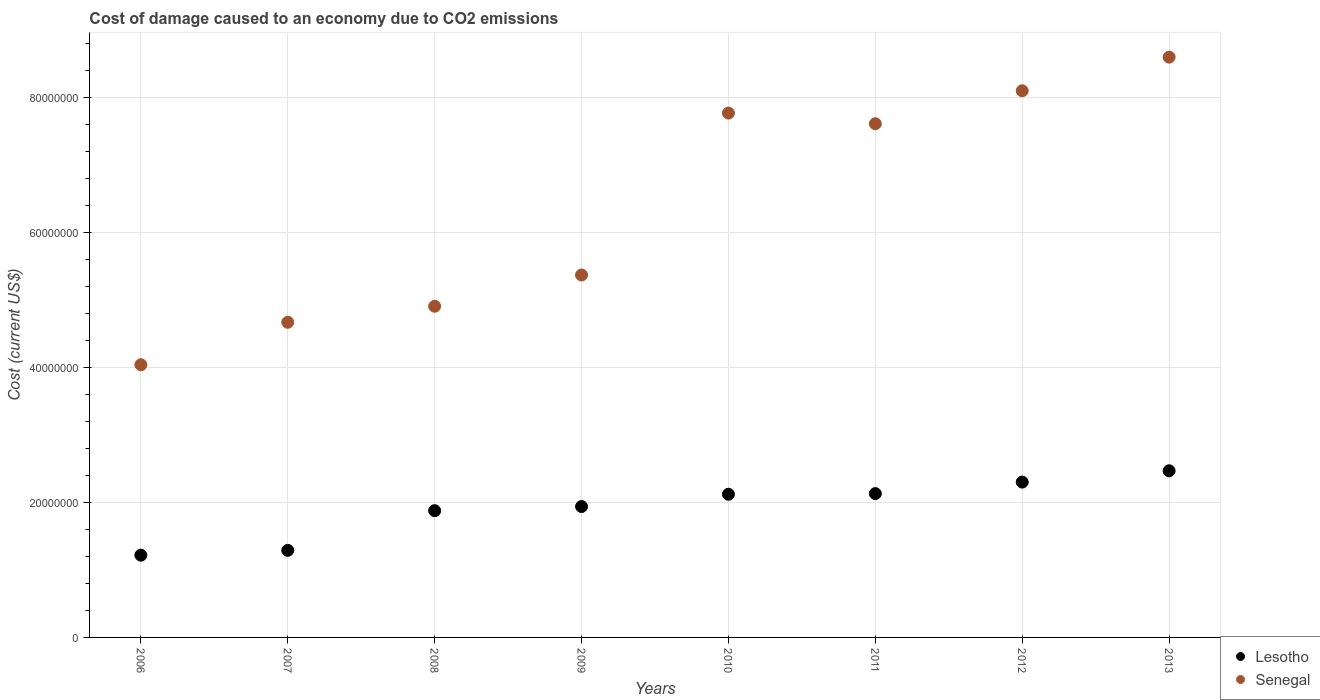How many different coloured dotlines are there?
Ensure brevity in your answer.  2. Is the number of dotlines equal to the number of legend labels?
Provide a succinct answer. Yes. What is the cost of damage caused due to CO2 emissisons in Lesotho in 2008?
Offer a very short reply. 1.88e+07. Across all years, what is the maximum cost of damage caused due to CO2 emissisons in Lesotho?
Your answer should be very brief. 2.47e+07. Across all years, what is the minimum cost of damage caused due to CO2 emissisons in Lesotho?
Make the answer very short. 1.22e+07. In which year was the cost of damage caused due to CO2 emissisons in Lesotho maximum?
Keep it short and to the point. 2013. In which year was the cost of damage caused due to CO2 emissisons in Lesotho minimum?
Your answer should be compact. 2006. What is the total cost of damage caused due to CO2 emissisons in Senegal in the graph?
Your response must be concise. 5.11e+08. What is the difference between the cost of damage caused due to CO2 emissisons in Lesotho in 2010 and that in 2012?
Ensure brevity in your answer.  -1.80e+06. What is the difference between the cost of damage caused due to CO2 emissisons in Senegal in 2011 and the cost of damage caused due to CO2 emissisons in Lesotho in 2012?
Your answer should be compact. 5.31e+07. What is the average cost of damage caused due to CO2 emissisons in Senegal per year?
Offer a very short reply. 6.39e+07. In the year 2010, what is the difference between the cost of damage caused due to CO2 emissisons in Lesotho and cost of damage caused due to CO2 emissisons in Senegal?
Your answer should be compact. -5.65e+07. In how many years, is the cost of damage caused due to CO2 emissisons in Senegal greater than 84000000 US$?
Keep it short and to the point. 1. What is the ratio of the cost of damage caused due to CO2 emissisons in Senegal in 2006 to that in 2007?
Provide a succinct answer. 0.87. Is the difference between the cost of damage caused due to CO2 emissisons in Lesotho in 2007 and 2010 greater than the difference between the cost of damage caused due to CO2 emissisons in Senegal in 2007 and 2010?
Ensure brevity in your answer.  Yes. What is the difference between the highest and the second highest cost of damage caused due to CO2 emissisons in Lesotho?
Make the answer very short. 1.68e+06. What is the difference between the highest and the lowest cost of damage caused due to CO2 emissisons in Lesotho?
Give a very brief answer. 1.25e+07. In how many years, is the cost of damage caused due to CO2 emissisons in Lesotho greater than the average cost of damage caused due to CO2 emissisons in Lesotho taken over all years?
Provide a succinct answer. 5. Is the sum of the cost of damage caused due to CO2 emissisons in Lesotho in 2009 and 2011 greater than the maximum cost of damage caused due to CO2 emissisons in Senegal across all years?
Your response must be concise. No. Is the cost of damage caused due to CO2 emissisons in Senegal strictly greater than the cost of damage caused due to CO2 emissisons in Lesotho over the years?
Your answer should be very brief. Yes. Is the cost of damage caused due to CO2 emissisons in Senegal strictly less than the cost of damage caused due to CO2 emissisons in Lesotho over the years?
Offer a terse response. No. How many dotlines are there?
Offer a terse response. 2. What is the difference between two consecutive major ticks on the Y-axis?
Offer a terse response. 2.00e+07. Are the values on the major ticks of Y-axis written in scientific E-notation?
Your answer should be compact. No. Does the graph contain any zero values?
Provide a succinct answer. No. Where does the legend appear in the graph?
Provide a short and direct response. Bottom right. How are the legend labels stacked?
Offer a terse response. Vertical. What is the title of the graph?
Your answer should be compact. Cost of damage caused to an economy due to CO2 emissions. Does "Rwanda" appear as one of the legend labels in the graph?
Offer a very short reply. No. What is the label or title of the X-axis?
Make the answer very short. Years. What is the label or title of the Y-axis?
Ensure brevity in your answer.  Cost (current US$). What is the Cost (current US$) of Lesotho in 2006?
Ensure brevity in your answer.  1.22e+07. What is the Cost (current US$) in Senegal in 2006?
Offer a terse response. 4.04e+07. What is the Cost (current US$) in Lesotho in 2007?
Offer a terse response. 1.29e+07. What is the Cost (current US$) in Senegal in 2007?
Your answer should be compact. 4.67e+07. What is the Cost (current US$) of Lesotho in 2008?
Your answer should be very brief. 1.88e+07. What is the Cost (current US$) of Senegal in 2008?
Provide a short and direct response. 4.91e+07. What is the Cost (current US$) in Lesotho in 2009?
Make the answer very short. 1.94e+07. What is the Cost (current US$) in Senegal in 2009?
Offer a terse response. 5.37e+07. What is the Cost (current US$) of Lesotho in 2010?
Keep it short and to the point. 2.12e+07. What is the Cost (current US$) in Senegal in 2010?
Your answer should be compact. 7.77e+07. What is the Cost (current US$) of Lesotho in 2011?
Offer a very short reply. 2.13e+07. What is the Cost (current US$) in Senegal in 2011?
Make the answer very short. 7.62e+07. What is the Cost (current US$) in Lesotho in 2012?
Provide a succinct answer. 2.30e+07. What is the Cost (current US$) of Senegal in 2012?
Make the answer very short. 8.11e+07. What is the Cost (current US$) of Lesotho in 2013?
Your answer should be compact. 2.47e+07. What is the Cost (current US$) in Senegal in 2013?
Make the answer very short. 8.60e+07. Across all years, what is the maximum Cost (current US$) in Lesotho?
Keep it short and to the point. 2.47e+07. Across all years, what is the maximum Cost (current US$) of Senegal?
Keep it short and to the point. 8.60e+07. Across all years, what is the minimum Cost (current US$) of Lesotho?
Offer a terse response. 1.22e+07. Across all years, what is the minimum Cost (current US$) of Senegal?
Keep it short and to the point. 4.04e+07. What is the total Cost (current US$) of Lesotho in the graph?
Ensure brevity in your answer.  1.54e+08. What is the total Cost (current US$) of Senegal in the graph?
Offer a terse response. 5.11e+08. What is the difference between the Cost (current US$) in Lesotho in 2006 and that in 2007?
Your answer should be compact. -7.13e+05. What is the difference between the Cost (current US$) of Senegal in 2006 and that in 2007?
Provide a succinct answer. -6.30e+06. What is the difference between the Cost (current US$) in Lesotho in 2006 and that in 2008?
Provide a short and direct response. -6.60e+06. What is the difference between the Cost (current US$) in Senegal in 2006 and that in 2008?
Make the answer very short. -8.67e+06. What is the difference between the Cost (current US$) in Lesotho in 2006 and that in 2009?
Ensure brevity in your answer.  -7.21e+06. What is the difference between the Cost (current US$) in Senegal in 2006 and that in 2009?
Provide a succinct answer. -1.33e+07. What is the difference between the Cost (current US$) of Lesotho in 2006 and that in 2010?
Offer a very short reply. -9.03e+06. What is the difference between the Cost (current US$) of Senegal in 2006 and that in 2010?
Make the answer very short. -3.73e+07. What is the difference between the Cost (current US$) in Lesotho in 2006 and that in 2011?
Give a very brief answer. -9.13e+06. What is the difference between the Cost (current US$) in Senegal in 2006 and that in 2011?
Make the answer very short. -3.57e+07. What is the difference between the Cost (current US$) of Lesotho in 2006 and that in 2012?
Provide a succinct answer. -1.08e+07. What is the difference between the Cost (current US$) in Senegal in 2006 and that in 2012?
Ensure brevity in your answer.  -4.06e+07. What is the difference between the Cost (current US$) of Lesotho in 2006 and that in 2013?
Give a very brief answer. -1.25e+07. What is the difference between the Cost (current US$) in Senegal in 2006 and that in 2013?
Offer a terse response. -4.56e+07. What is the difference between the Cost (current US$) in Lesotho in 2007 and that in 2008?
Make the answer very short. -5.88e+06. What is the difference between the Cost (current US$) in Senegal in 2007 and that in 2008?
Make the answer very short. -2.38e+06. What is the difference between the Cost (current US$) in Lesotho in 2007 and that in 2009?
Offer a terse response. -6.50e+06. What is the difference between the Cost (current US$) of Senegal in 2007 and that in 2009?
Give a very brief answer. -7.01e+06. What is the difference between the Cost (current US$) of Lesotho in 2007 and that in 2010?
Provide a succinct answer. -8.32e+06. What is the difference between the Cost (current US$) in Senegal in 2007 and that in 2010?
Keep it short and to the point. -3.10e+07. What is the difference between the Cost (current US$) of Lesotho in 2007 and that in 2011?
Your response must be concise. -8.42e+06. What is the difference between the Cost (current US$) in Senegal in 2007 and that in 2011?
Offer a very short reply. -2.94e+07. What is the difference between the Cost (current US$) of Lesotho in 2007 and that in 2012?
Offer a very short reply. -1.01e+07. What is the difference between the Cost (current US$) in Senegal in 2007 and that in 2012?
Offer a very short reply. -3.43e+07. What is the difference between the Cost (current US$) in Lesotho in 2007 and that in 2013?
Offer a terse response. -1.18e+07. What is the difference between the Cost (current US$) of Senegal in 2007 and that in 2013?
Keep it short and to the point. -3.93e+07. What is the difference between the Cost (current US$) of Lesotho in 2008 and that in 2009?
Make the answer very short. -6.11e+05. What is the difference between the Cost (current US$) of Senegal in 2008 and that in 2009?
Provide a succinct answer. -4.63e+06. What is the difference between the Cost (current US$) in Lesotho in 2008 and that in 2010?
Provide a short and direct response. -2.43e+06. What is the difference between the Cost (current US$) of Senegal in 2008 and that in 2010?
Offer a very short reply. -2.86e+07. What is the difference between the Cost (current US$) in Lesotho in 2008 and that in 2011?
Keep it short and to the point. -2.53e+06. What is the difference between the Cost (current US$) in Senegal in 2008 and that in 2011?
Offer a very short reply. -2.71e+07. What is the difference between the Cost (current US$) in Lesotho in 2008 and that in 2012?
Keep it short and to the point. -4.24e+06. What is the difference between the Cost (current US$) of Senegal in 2008 and that in 2012?
Provide a succinct answer. -3.20e+07. What is the difference between the Cost (current US$) of Lesotho in 2008 and that in 2013?
Your response must be concise. -5.91e+06. What is the difference between the Cost (current US$) in Senegal in 2008 and that in 2013?
Provide a short and direct response. -3.69e+07. What is the difference between the Cost (current US$) in Lesotho in 2009 and that in 2010?
Your response must be concise. -1.82e+06. What is the difference between the Cost (current US$) in Senegal in 2009 and that in 2010?
Your answer should be compact. -2.40e+07. What is the difference between the Cost (current US$) of Lesotho in 2009 and that in 2011?
Offer a terse response. -1.92e+06. What is the difference between the Cost (current US$) in Senegal in 2009 and that in 2011?
Ensure brevity in your answer.  -2.24e+07. What is the difference between the Cost (current US$) in Lesotho in 2009 and that in 2012?
Ensure brevity in your answer.  -3.63e+06. What is the difference between the Cost (current US$) in Senegal in 2009 and that in 2012?
Give a very brief answer. -2.73e+07. What is the difference between the Cost (current US$) of Lesotho in 2009 and that in 2013?
Your answer should be compact. -5.30e+06. What is the difference between the Cost (current US$) of Senegal in 2009 and that in 2013?
Your response must be concise. -3.23e+07. What is the difference between the Cost (current US$) in Lesotho in 2010 and that in 2011?
Provide a succinct answer. -9.74e+04. What is the difference between the Cost (current US$) in Senegal in 2010 and that in 2011?
Offer a very short reply. 1.58e+06. What is the difference between the Cost (current US$) in Lesotho in 2010 and that in 2012?
Your response must be concise. -1.80e+06. What is the difference between the Cost (current US$) of Senegal in 2010 and that in 2012?
Provide a succinct answer. -3.31e+06. What is the difference between the Cost (current US$) of Lesotho in 2010 and that in 2013?
Your response must be concise. -3.48e+06. What is the difference between the Cost (current US$) in Senegal in 2010 and that in 2013?
Provide a short and direct response. -8.29e+06. What is the difference between the Cost (current US$) of Lesotho in 2011 and that in 2012?
Your answer should be compact. -1.71e+06. What is the difference between the Cost (current US$) in Senegal in 2011 and that in 2012?
Provide a short and direct response. -4.89e+06. What is the difference between the Cost (current US$) in Lesotho in 2011 and that in 2013?
Offer a terse response. -3.38e+06. What is the difference between the Cost (current US$) of Senegal in 2011 and that in 2013?
Make the answer very short. -9.87e+06. What is the difference between the Cost (current US$) of Lesotho in 2012 and that in 2013?
Ensure brevity in your answer.  -1.68e+06. What is the difference between the Cost (current US$) in Senegal in 2012 and that in 2013?
Ensure brevity in your answer.  -4.98e+06. What is the difference between the Cost (current US$) of Lesotho in 2006 and the Cost (current US$) of Senegal in 2007?
Offer a very short reply. -3.45e+07. What is the difference between the Cost (current US$) in Lesotho in 2006 and the Cost (current US$) in Senegal in 2008?
Provide a succinct answer. -3.69e+07. What is the difference between the Cost (current US$) of Lesotho in 2006 and the Cost (current US$) of Senegal in 2009?
Ensure brevity in your answer.  -4.15e+07. What is the difference between the Cost (current US$) of Lesotho in 2006 and the Cost (current US$) of Senegal in 2010?
Give a very brief answer. -6.55e+07. What is the difference between the Cost (current US$) in Lesotho in 2006 and the Cost (current US$) in Senegal in 2011?
Provide a succinct answer. -6.40e+07. What is the difference between the Cost (current US$) in Lesotho in 2006 and the Cost (current US$) in Senegal in 2012?
Your answer should be compact. -6.89e+07. What is the difference between the Cost (current US$) of Lesotho in 2006 and the Cost (current US$) of Senegal in 2013?
Make the answer very short. -7.38e+07. What is the difference between the Cost (current US$) in Lesotho in 2007 and the Cost (current US$) in Senegal in 2008?
Keep it short and to the point. -3.62e+07. What is the difference between the Cost (current US$) of Lesotho in 2007 and the Cost (current US$) of Senegal in 2009?
Your answer should be compact. -4.08e+07. What is the difference between the Cost (current US$) of Lesotho in 2007 and the Cost (current US$) of Senegal in 2010?
Keep it short and to the point. -6.48e+07. What is the difference between the Cost (current US$) of Lesotho in 2007 and the Cost (current US$) of Senegal in 2011?
Keep it short and to the point. -6.33e+07. What is the difference between the Cost (current US$) in Lesotho in 2007 and the Cost (current US$) in Senegal in 2012?
Your answer should be very brief. -6.81e+07. What is the difference between the Cost (current US$) in Lesotho in 2007 and the Cost (current US$) in Senegal in 2013?
Your response must be concise. -7.31e+07. What is the difference between the Cost (current US$) of Lesotho in 2008 and the Cost (current US$) of Senegal in 2009?
Your answer should be very brief. -3.49e+07. What is the difference between the Cost (current US$) of Lesotho in 2008 and the Cost (current US$) of Senegal in 2010?
Make the answer very short. -5.90e+07. What is the difference between the Cost (current US$) of Lesotho in 2008 and the Cost (current US$) of Senegal in 2011?
Make the answer very short. -5.74e+07. What is the difference between the Cost (current US$) of Lesotho in 2008 and the Cost (current US$) of Senegal in 2012?
Provide a succinct answer. -6.23e+07. What is the difference between the Cost (current US$) in Lesotho in 2008 and the Cost (current US$) in Senegal in 2013?
Keep it short and to the point. -6.72e+07. What is the difference between the Cost (current US$) of Lesotho in 2009 and the Cost (current US$) of Senegal in 2010?
Your response must be concise. -5.83e+07. What is the difference between the Cost (current US$) in Lesotho in 2009 and the Cost (current US$) in Senegal in 2011?
Offer a terse response. -5.68e+07. What is the difference between the Cost (current US$) of Lesotho in 2009 and the Cost (current US$) of Senegal in 2012?
Provide a succinct answer. -6.17e+07. What is the difference between the Cost (current US$) in Lesotho in 2009 and the Cost (current US$) in Senegal in 2013?
Your response must be concise. -6.66e+07. What is the difference between the Cost (current US$) of Lesotho in 2010 and the Cost (current US$) of Senegal in 2011?
Provide a succinct answer. -5.49e+07. What is the difference between the Cost (current US$) of Lesotho in 2010 and the Cost (current US$) of Senegal in 2012?
Provide a succinct answer. -5.98e+07. What is the difference between the Cost (current US$) in Lesotho in 2010 and the Cost (current US$) in Senegal in 2013?
Your response must be concise. -6.48e+07. What is the difference between the Cost (current US$) in Lesotho in 2011 and the Cost (current US$) in Senegal in 2012?
Make the answer very short. -5.97e+07. What is the difference between the Cost (current US$) in Lesotho in 2011 and the Cost (current US$) in Senegal in 2013?
Provide a short and direct response. -6.47e+07. What is the difference between the Cost (current US$) of Lesotho in 2012 and the Cost (current US$) of Senegal in 2013?
Your answer should be compact. -6.30e+07. What is the average Cost (current US$) of Lesotho per year?
Ensure brevity in your answer.  1.92e+07. What is the average Cost (current US$) in Senegal per year?
Ensure brevity in your answer.  6.39e+07. In the year 2006, what is the difference between the Cost (current US$) of Lesotho and Cost (current US$) of Senegal?
Your answer should be compact. -2.82e+07. In the year 2007, what is the difference between the Cost (current US$) of Lesotho and Cost (current US$) of Senegal?
Your answer should be compact. -3.38e+07. In the year 2008, what is the difference between the Cost (current US$) in Lesotho and Cost (current US$) in Senegal?
Offer a terse response. -3.03e+07. In the year 2009, what is the difference between the Cost (current US$) in Lesotho and Cost (current US$) in Senegal?
Provide a succinct answer. -3.43e+07. In the year 2010, what is the difference between the Cost (current US$) in Lesotho and Cost (current US$) in Senegal?
Keep it short and to the point. -5.65e+07. In the year 2011, what is the difference between the Cost (current US$) of Lesotho and Cost (current US$) of Senegal?
Give a very brief answer. -5.48e+07. In the year 2012, what is the difference between the Cost (current US$) of Lesotho and Cost (current US$) of Senegal?
Offer a very short reply. -5.80e+07. In the year 2013, what is the difference between the Cost (current US$) of Lesotho and Cost (current US$) of Senegal?
Keep it short and to the point. -6.13e+07. What is the ratio of the Cost (current US$) of Lesotho in 2006 to that in 2007?
Your answer should be compact. 0.94. What is the ratio of the Cost (current US$) of Senegal in 2006 to that in 2007?
Your answer should be very brief. 0.87. What is the ratio of the Cost (current US$) of Lesotho in 2006 to that in 2008?
Make the answer very short. 0.65. What is the ratio of the Cost (current US$) in Senegal in 2006 to that in 2008?
Make the answer very short. 0.82. What is the ratio of the Cost (current US$) in Lesotho in 2006 to that in 2009?
Ensure brevity in your answer.  0.63. What is the ratio of the Cost (current US$) of Senegal in 2006 to that in 2009?
Provide a succinct answer. 0.75. What is the ratio of the Cost (current US$) of Lesotho in 2006 to that in 2010?
Your answer should be very brief. 0.57. What is the ratio of the Cost (current US$) in Senegal in 2006 to that in 2010?
Offer a terse response. 0.52. What is the ratio of the Cost (current US$) of Lesotho in 2006 to that in 2011?
Give a very brief answer. 0.57. What is the ratio of the Cost (current US$) in Senegal in 2006 to that in 2011?
Offer a terse response. 0.53. What is the ratio of the Cost (current US$) in Lesotho in 2006 to that in 2012?
Make the answer very short. 0.53. What is the ratio of the Cost (current US$) in Senegal in 2006 to that in 2012?
Provide a short and direct response. 0.5. What is the ratio of the Cost (current US$) in Lesotho in 2006 to that in 2013?
Provide a short and direct response. 0.49. What is the ratio of the Cost (current US$) of Senegal in 2006 to that in 2013?
Your response must be concise. 0.47. What is the ratio of the Cost (current US$) of Lesotho in 2007 to that in 2008?
Provide a succinct answer. 0.69. What is the ratio of the Cost (current US$) of Senegal in 2007 to that in 2008?
Keep it short and to the point. 0.95. What is the ratio of the Cost (current US$) of Lesotho in 2007 to that in 2009?
Your response must be concise. 0.67. What is the ratio of the Cost (current US$) in Senegal in 2007 to that in 2009?
Your response must be concise. 0.87. What is the ratio of the Cost (current US$) of Lesotho in 2007 to that in 2010?
Provide a succinct answer. 0.61. What is the ratio of the Cost (current US$) in Senegal in 2007 to that in 2010?
Your answer should be compact. 0.6. What is the ratio of the Cost (current US$) in Lesotho in 2007 to that in 2011?
Offer a terse response. 0.61. What is the ratio of the Cost (current US$) in Senegal in 2007 to that in 2011?
Your response must be concise. 0.61. What is the ratio of the Cost (current US$) in Lesotho in 2007 to that in 2012?
Ensure brevity in your answer.  0.56. What is the ratio of the Cost (current US$) in Senegal in 2007 to that in 2012?
Offer a very short reply. 0.58. What is the ratio of the Cost (current US$) of Lesotho in 2007 to that in 2013?
Your answer should be compact. 0.52. What is the ratio of the Cost (current US$) in Senegal in 2007 to that in 2013?
Keep it short and to the point. 0.54. What is the ratio of the Cost (current US$) in Lesotho in 2008 to that in 2009?
Provide a succinct answer. 0.97. What is the ratio of the Cost (current US$) in Senegal in 2008 to that in 2009?
Offer a terse response. 0.91. What is the ratio of the Cost (current US$) in Lesotho in 2008 to that in 2010?
Make the answer very short. 0.89. What is the ratio of the Cost (current US$) of Senegal in 2008 to that in 2010?
Keep it short and to the point. 0.63. What is the ratio of the Cost (current US$) in Lesotho in 2008 to that in 2011?
Provide a short and direct response. 0.88. What is the ratio of the Cost (current US$) of Senegal in 2008 to that in 2011?
Provide a short and direct response. 0.64. What is the ratio of the Cost (current US$) of Lesotho in 2008 to that in 2012?
Your answer should be very brief. 0.82. What is the ratio of the Cost (current US$) in Senegal in 2008 to that in 2012?
Your answer should be very brief. 0.61. What is the ratio of the Cost (current US$) of Lesotho in 2008 to that in 2013?
Make the answer very short. 0.76. What is the ratio of the Cost (current US$) in Senegal in 2008 to that in 2013?
Your response must be concise. 0.57. What is the ratio of the Cost (current US$) in Lesotho in 2009 to that in 2010?
Make the answer very short. 0.91. What is the ratio of the Cost (current US$) of Senegal in 2009 to that in 2010?
Ensure brevity in your answer.  0.69. What is the ratio of the Cost (current US$) in Lesotho in 2009 to that in 2011?
Your answer should be compact. 0.91. What is the ratio of the Cost (current US$) in Senegal in 2009 to that in 2011?
Offer a terse response. 0.71. What is the ratio of the Cost (current US$) in Lesotho in 2009 to that in 2012?
Offer a very short reply. 0.84. What is the ratio of the Cost (current US$) of Senegal in 2009 to that in 2012?
Your response must be concise. 0.66. What is the ratio of the Cost (current US$) in Lesotho in 2009 to that in 2013?
Keep it short and to the point. 0.79. What is the ratio of the Cost (current US$) in Senegal in 2009 to that in 2013?
Keep it short and to the point. 0.62. What is the ratio of the Cost (current US$) in Senegal in 2010 to that in 2011?
Offer a terse response. 1.02. What is the ratio of the Cost (current US$) in Lesotho in 2010 to that in 2012?
Provide a succinct answer. 0.92. What is the ratio of the Cost (current US$) in Senegal in 2010 to that in 2012?
Your response must be concise. 0.96. What is the ratio of the Cost (current US$) in Lesotho in 2010 to that in 2013?
Your answer should be very brief. 0.86. What is the ratio of the Cost (current US$) in Senegal in 2010 to that in 2013?
Your response must be concise. 0.9. What is the ratio of the Cost (current US$) in Lesotho in 2011 to that in 2012?
Make the answer very short. 0.93. What is the ratio of the Cost (current US$) in Senegal in 2011 to that in 2012?
Provide a succinct answer. 0.94. What is the ratio of the Cost (current US$) of Lesotho in 2011 to that in 2013?
Your answer should be very brief. 0.86. What is the ratio of the Cost (current US$) in Senegal in 2011 to that in 2013?
Give a very brief answer. 0.89. What is the ratio of the Cost (current US$) in Lesotho in 2012 to that in 2013?
Keep it short and to the point. 0.93. What is the ratio of the Cost (current US$) in Senegal in 2012 to that in 2013?
Your response must be concise. 0.94. What is the difference between the highest and the second highest Cost (current US$) of Lesotho?
Keep it short and to the point. 1.68e+06. What is the difference between the highest and the second highest Cost (current US$) in Senegal?
Your response must be concise. 4.98e+06. What is the difference between the highest and the lowest Cost (current US$) in Lesotho?
Provide a succinct answer. 1.25e+07. What is the difference between the highest and the lowest Cost (current US$) of Senegal?
Make the answer very short. 4.56e+07. 